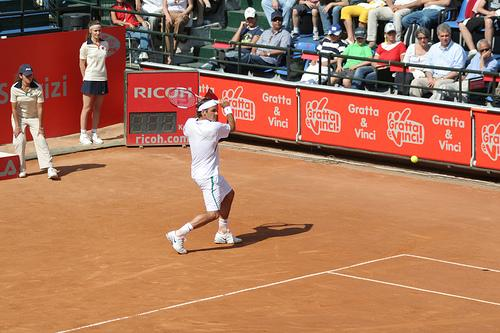Why is the man swinging his arms?

Choices:
A) dancing
B) stretching
C) swatting flies
D) swatting ball swatting ball 